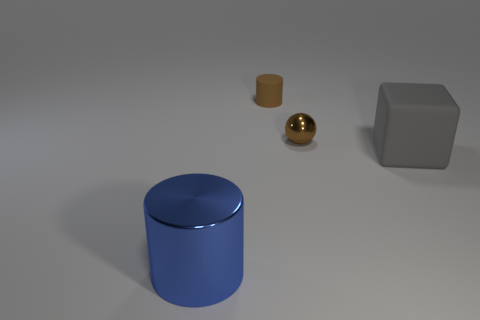What is the shape of the metallic thing to the left of the small cylinder?
Make the answer very short. Cylinder. What number of brown spheres are left of the large gray rubber block that is to the right of the thing in front of the gray matte cube?
Your response must be concise. 1. There is a cylinder behind the gray rubber thing; is its color the same as the rubber cube?
Make the answer very short. No. What number of other objects are there of the same shape as the large gray object?
Your answer should be very brief. 0. How many other things are the same material as the sphere?
Your response must be concise. 1. What is the big thing left of the big thing that is behind the metallic thing to the left of the brown cylinder made of?
Make the answer very short. Metal. Is the tiny sphere made of the same material as the blue cylinder?
Keep it short and to the point. Yes. What number of spheres are large metallic objects or metallic things?
Keep it short and to the point. 1. What color is the rubber thing behind the big matte object?
Keep it short and to the point. Brown. What number of shiny objects are big cubes or blue cylinders?
Offer a very short reply. 1. 